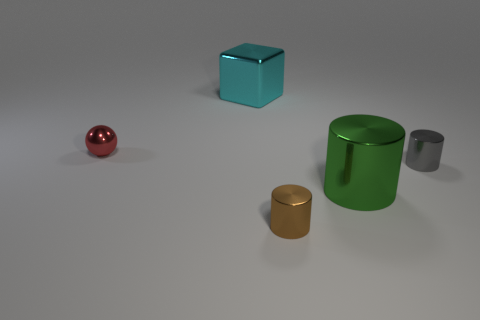Subtract all gray cylinders. How many cylinders are left? 2 Add 5 tiny red shiny balls. How many objects exist? 10 Subtract all gray cylinders. How many cylinders are left? 2 Subtract all cubes. How many objects are left? 4 Subtract all brown spheres. Subtract all gray cubes. How many spheres are left? 1 Subtract all small metallic cylinders. Subtract all large things. How many objects are left? 1 Add 2 small gray cylinders. How many small gray cylinders are left? 3 Add 5 brown matte balls. How many brown matte balls exist? 5 Subtract 0 brown balls. How many objects are left? 5 